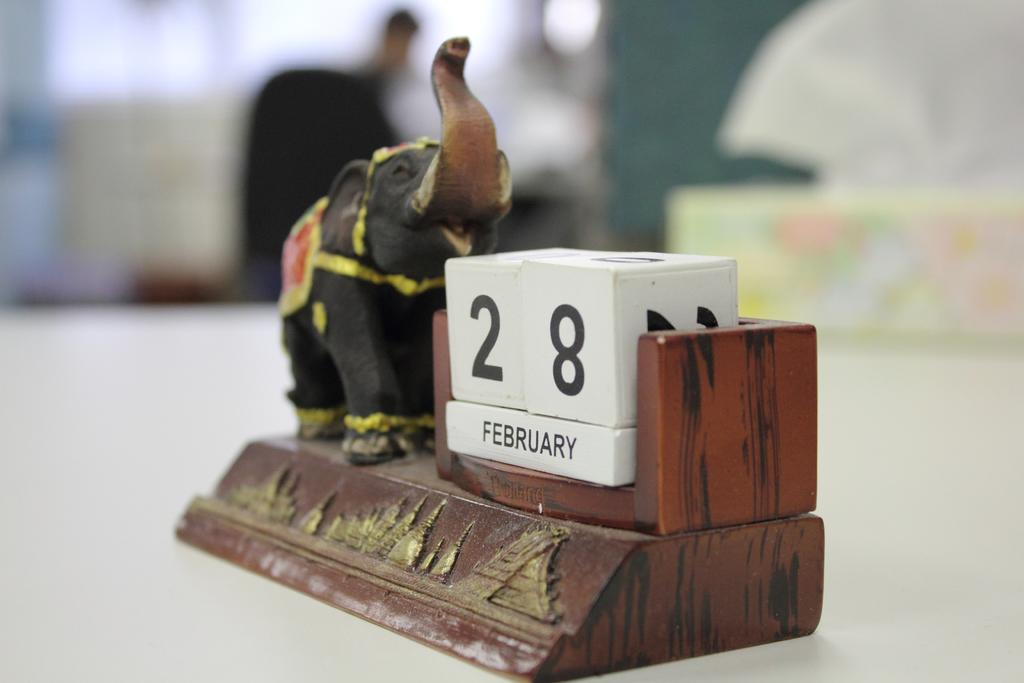<image>
Give a short and clear explanation of the subsequent image. Next to an elephant is the word February. 